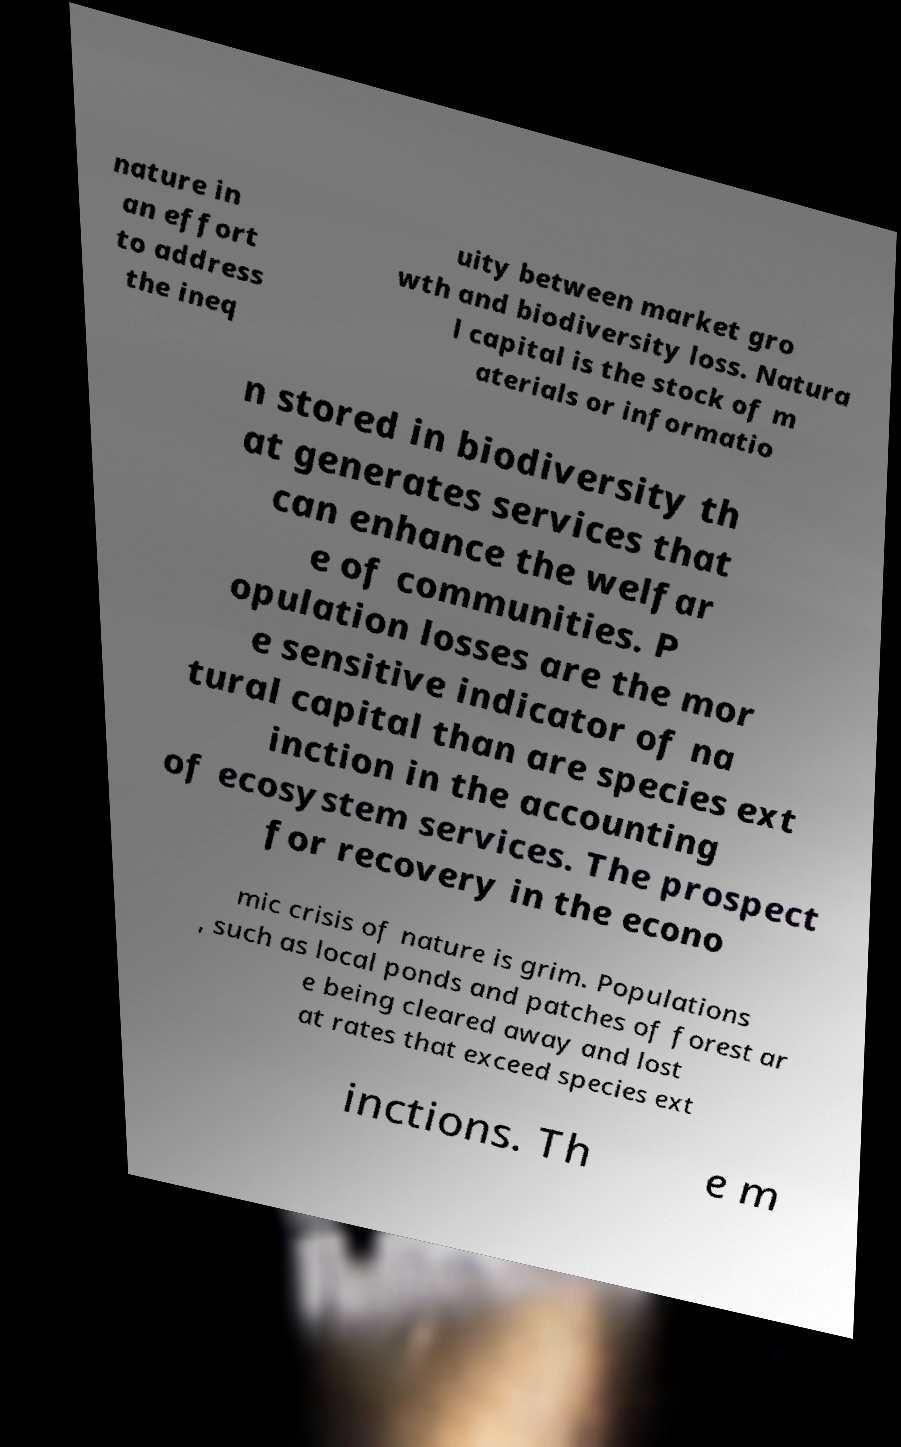For documentation purposes, I need the text within this image transcribed. Could you provide that? nature in an effort to address the ineq uity between market gro wth and biodiversity loss. Natura l capital is the stock of m aterials or informatio n stored in biodiversity th at generates services that can enhance the welfar e of communities. P opulation losses are the mor e sensitive indicator of na tural capital than are species ext inction in the accounting of ecosystem services. The prospect for recovery in the econo mic crisis of nature is grim. Populations , such as local ponds and patches of forest ar e being cleared away and lost at rates that exceed species ext inctions. Th e m 